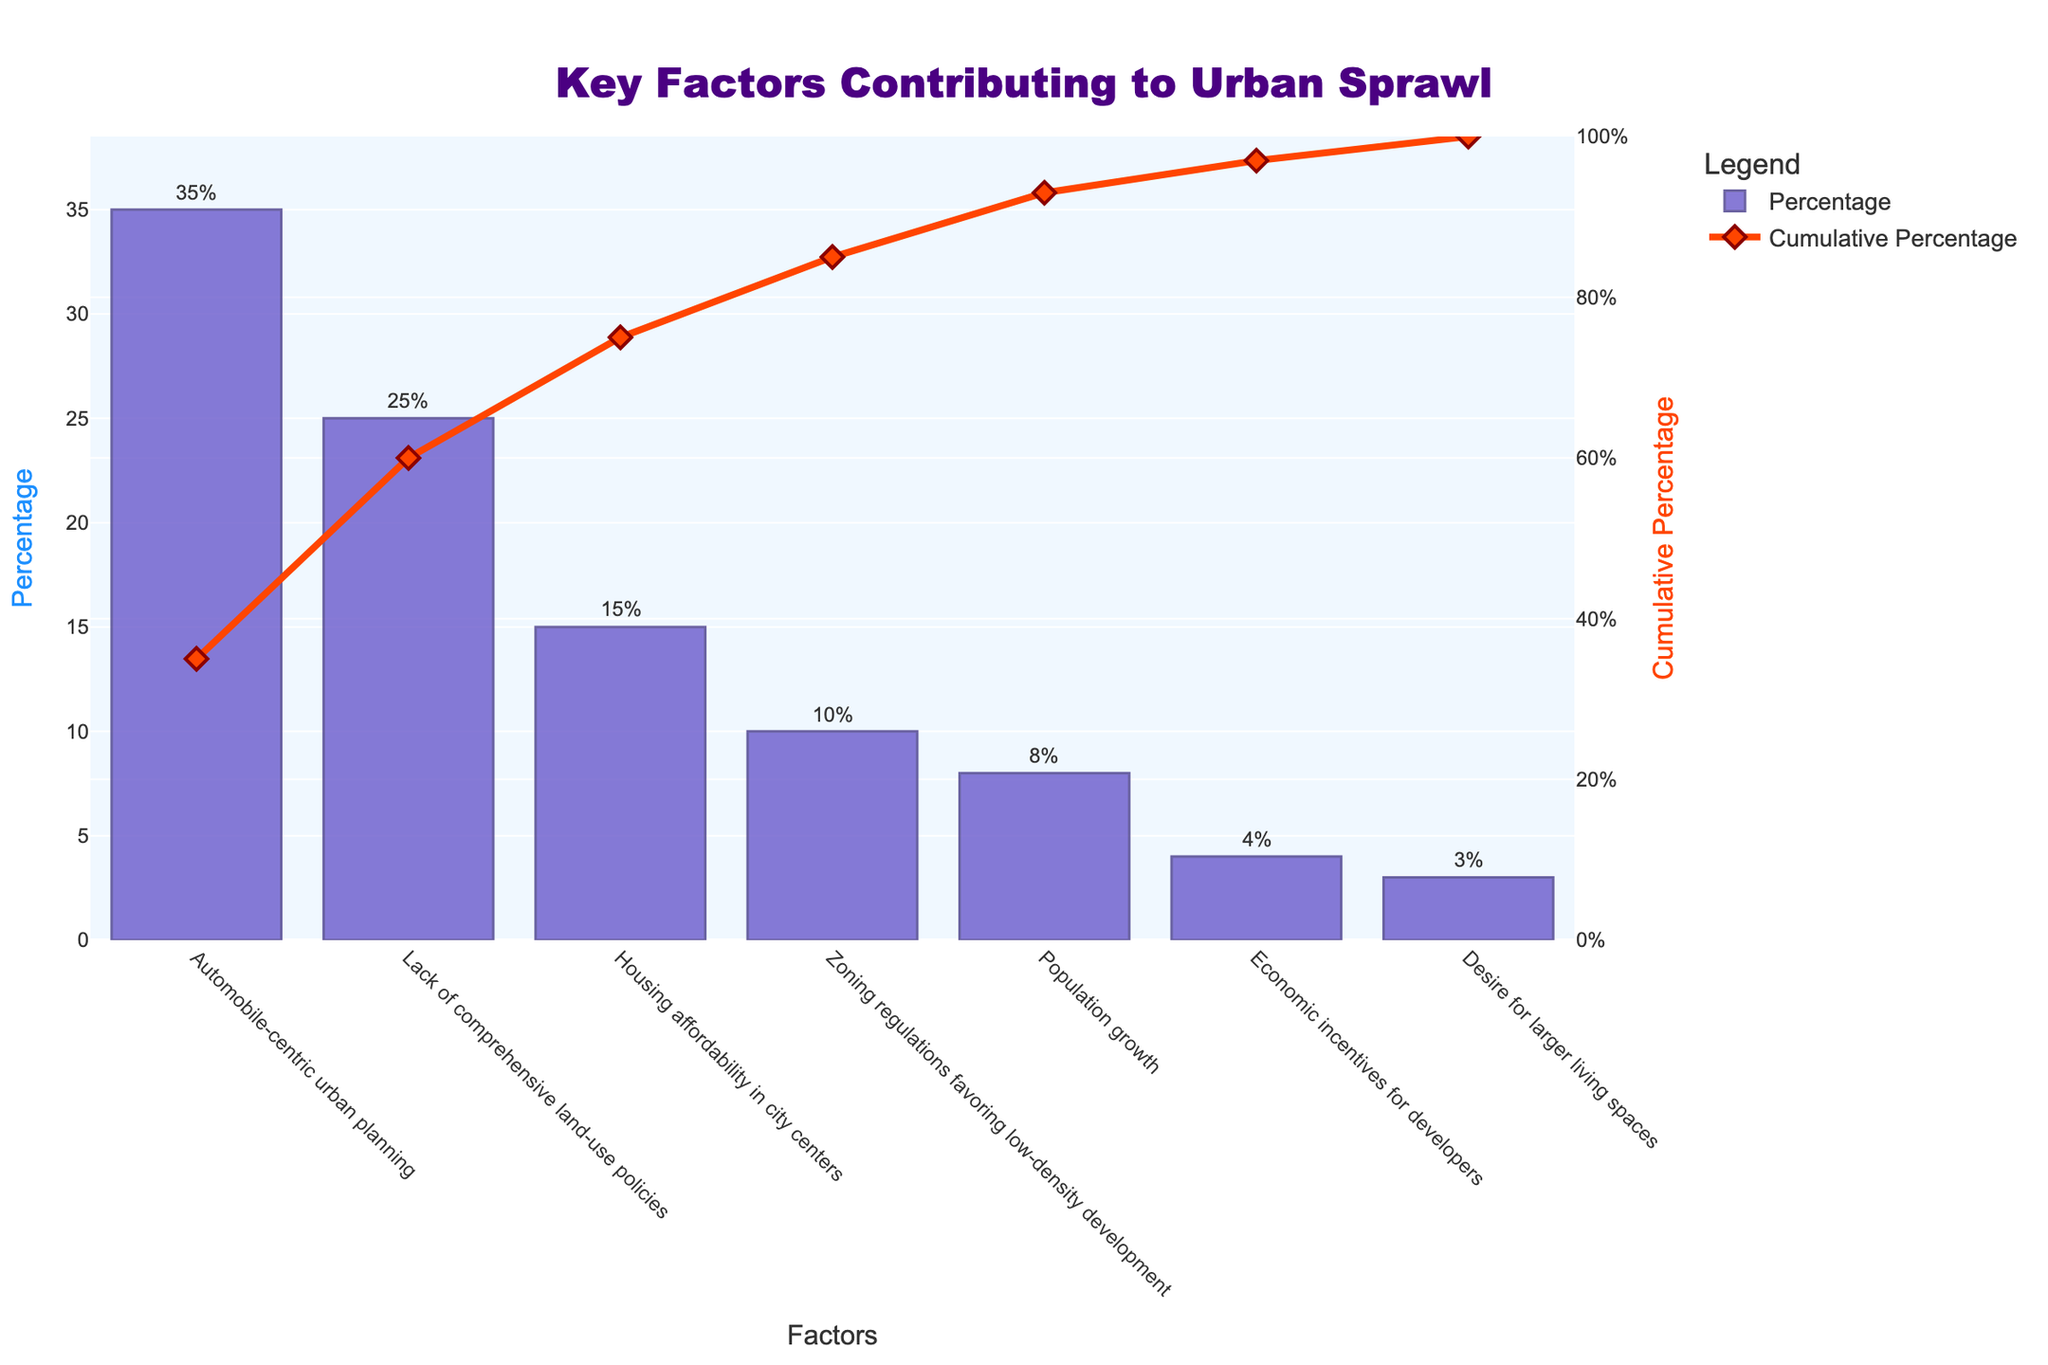What is the title of the chart? The title is located at the top of the chart and is written in bold, larger font.
Answer: Key Factors Contributing to Urban Sprawl Which factor contributes the most to urban sprawl? The factor with the highest bar represents the largest contribution. This factor has a 35% contribution according to the chart.
Answer: Automobile-centric urban planning What is the cumulative percentage after including the top three factors? To find this, add the cumulative percentages for the top three factors: 35%, 25%, and 15%. The cumulative percentage after these three is reported in the line trace for the factor "Housing affordability in city centers".
Answer: 75% Which factor has a 10% contribution to urban sprawl? The bar with the height corresponding to 10% is visually identified. Then, the label at the base of this bar provides the factor's name.
Answer: Zoning regulations favoring low-density development How does the contribution of "Economic incentives for developers" compare to "Population growth"? Compare the heights of the bars for these two factors. "Population growth" has a bar at 8%, and "Economic incentives for developers" is at 4%.
Answer: Economic incentives for developers contribute less than Population growth What is the cumulative percentage after including the factor "Zoning regulations favoring low-density development"? Sum the percentages up to and including "Zoning regulations favoring low-density development": 35% + 25% + 15% + 10%. The line trace on the chart would confirm this cumulative sum.
Answer: 85% By how much does "Lack of comprehensive land-use policies" contribute more than "Population growth"? Subtract the percentage for "Population growth" from the percentage for "Lack of comprehensive land-use policies": 25% - 8%.
Answer: 17% What is the percentage contribution of the least significant factor? Look for the smallest bar and read the percentage associated with it. This factor is "Desire for larger living spaces".
Answer: 3% Which color represents the bars and which color represents the line trace? The bar's color and the line trace's color can be identified by the legend or by visual inspection. The bars are colored in a shade of purple, and the line is in orange.
Answer: Bars are purple, line is orange How many factors contribute less than 10% each? Count the bars that have a height less than 10% on the y-axis. Those factors are "Population growth", "Economic incentives for developers", and "Desire for larger living spaces".
Answer: 3 